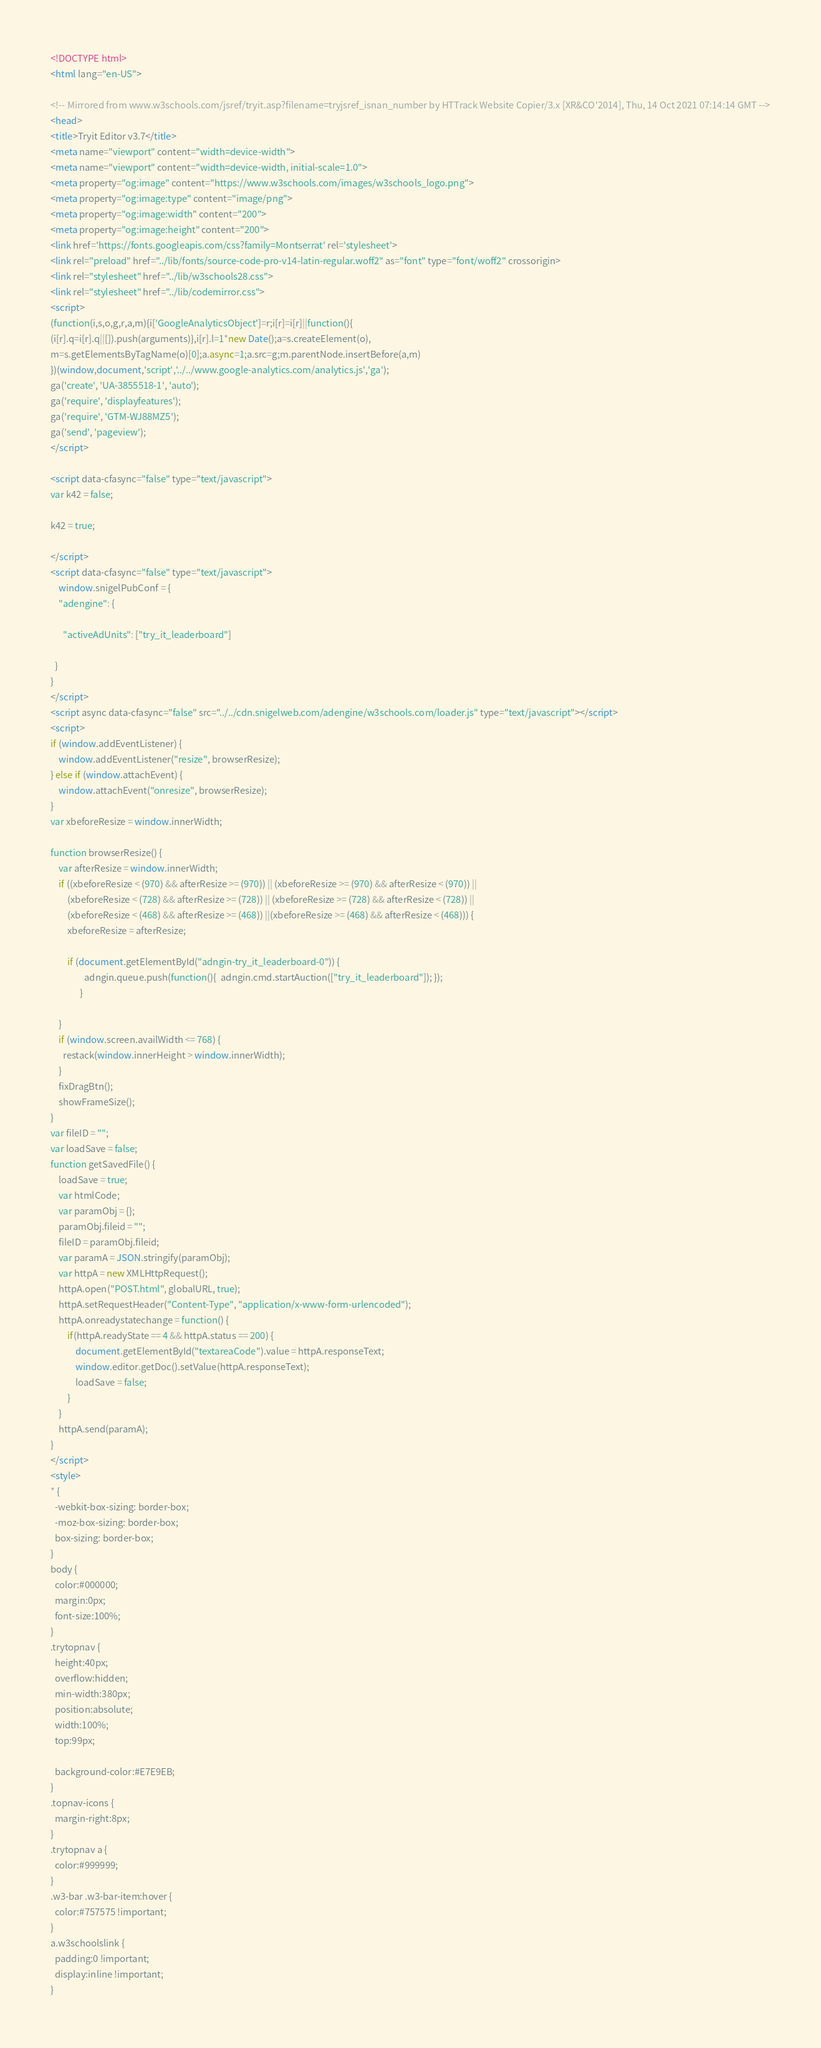Convert code to text. <code><loc_0><loc_0><loc_500><loc_500><_HTML_>
<!DOCTYPE html>
<html lang="en-US">

<!-- Mirrored from www.w3schools.com/jsref/tryit.asp?filename=tryjsref_isnan_number by HTTrack Website Copier/3.x [XR&CO'2014], Thu, 14 Oct 2021 07:14:14 GMT -->
<head>
<title>Tryit Editor v3.7</title>
<meta name="viewport" content="width=device-width">
<meta name="viewport" content="width=device-width, initial-scale=1.0">
<meta property="og:image" content="https://www.w3schools.com/images/w3schools_logo.png">
<meta property="og:image:type" content="image/png">
<meta property="og:image:width" content="200">
<meta property="og:image:height" content="200">
<link href='https://fonts.googleapis.com/css?family=Montserrat' rel='stylesheet'>
<link rel="preload" href="../lib/fonts/source-code-pro-v14-latin-regular.woff2" as="font" type="font/woff2" crossorigin>
<link rel="stylesheet" href="../lib/w3schools28.css">
<link rel="stylesheet" href="../lib/codemirror.css">
<script>
(function(i,s,o,g,r,a,m){i['GoogleAnalyticsObject']=r;i[r]=i[r]||function(){
(i[r].q=i[r].q||[]).push(arguments)},i[r].l=1*new Date();a=s.createElement(o),
m=s.getElementsByTagName(o)[0];a.async=1;a.src=g;m.parentNode.insertBefore(a,m)
})(window,document,'script','../../www.google-analytics.com/analytics.js','ga');
ga('create', 'UA-3855518-1', 'auto');
ga('require', 'displayfeatures');
ga('require', 'GTM-WJ88MZ5');
ga('send', 'pageview');
</script>

<script data-cfasync="false" type="text/javascript">
var k42 = false;

k42 = true;

</script>
<script data-cfasync="false" type="text/javascript">
    window.snigelPubConf = {
    "adengine": {

      "activeAdUnits": ["try_it_leaderboard"]

  }
}
</script>
<script async data-cfasync="false" src="../../cdn.snigelweb.com/adengine/w3schools.com/loader.js" type="text/javascript"></script>
<script>
if (window.addEventListener) {              
    window.addEventListener("resize", browserResize);
} else if (window.attachEvent) {                 
    window.attachEvent("onresize", browserResize);
}
var xbeforeResize = window.innerWidth;

function browserResize() {
    var afterResize = window.innerWidth;
    if ((xbeforeResize < (970) && afterResize >= (970)) || (xbeforeResize >= (970) && afterResize < (970)) ||
        (xbeforeResize < (728) && afterResize >= (728)) || (xbeforeResize >= (728) && afterResize < (728)) ||
        (xbeforeResize < (468) && afterResize >= (468)) ||(xbeforeResize >= (468) && afterResize < (468))) {
        xbeforeResize = afterResize;
        
        if (document.getElementById("adngin-try_it_leaderboard-0")) {
                adngin.queue.push(function(){  adngin.cmd.startAuction(["try_it_leaderboard"]); });
              }
         
    }
    if (window.screen.availWidth <= 768) {
      restack(window.innerHeight > window.innerWidth);
    }
    fixDragBtn();
    showFrameSize();    
}
var fileID = "";
var loadSave = false;
function getSavedFile() {
    loadSave = true;
    var htmlCode;
    var paramObj = {};
    paramObj.fileid = "";
    fileID = paramObj.fileid;
    var paramA = JSON.stringify(paramObj);
    var httpA = new XMLHttpRequest();
    httpA.open("POST.html", globalURL, true);
    httpA.setRequestHeader("Content-Type", "application/x-www-form-urlencoded");
    httpA.onreadystatechange = function() {
        if(httpA.readyState == 4 && httpA.status == 200) {
            document.getElementById("textareaCode").value = httpA.responseText;
            window.editor.getDoc().setValue(httpA.responseText);
            loadSave = false;
        }
    }
    httpA.send(paramA);   
}
</script>
<style>
* {
  -webkit-box-sizing: border-box;
  -moz-box-sizing: border-box;
  box-sizing: border-box;
}
body {
  color:#000000;
  margin:0px;
  font-size:100%;
}
.trytopnav {
  height:40px;
  overflow:hidden;
  min-width:380px;
  position:absolute;
  width:100%;
  top:99px;

  background-color:#E7E9EB;
}
.topnav-icons {
  margin-right:8px;
}
.trytopnav a {
  color:#999999;
}
.w3-bar .w3-bar-item:hover {
  color:#757575 !important;
}
a.w3schoolslink {
  padding:0 !important;
  display:inline !important;
}</code> 